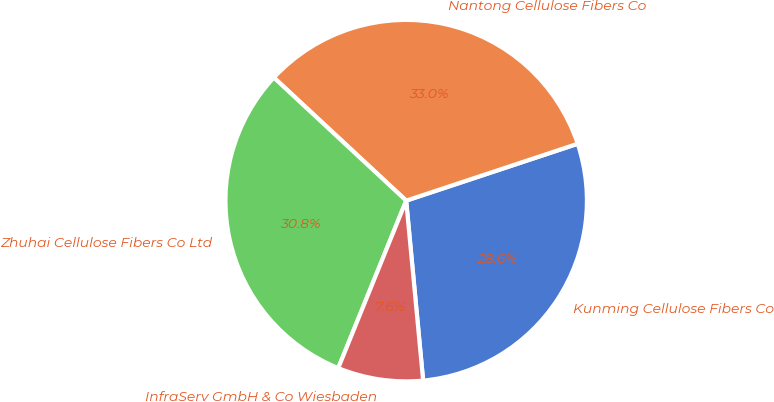<chart> <loc_0><loc_0><loc_500><loc_500><pie_chart><fcel>Kunming Cellulose Fibers Co<fcel>Nantong Cellulose Fibers Co<fcel>Zhuhai Cellulose Fibers Co Ltd<fcel>InfraServ GmbH & Co Wiesbaden<nl><fcel>28.6%<fcel>32.98%<fcel>30.79%<fcel>7.63%<nl></chart> 